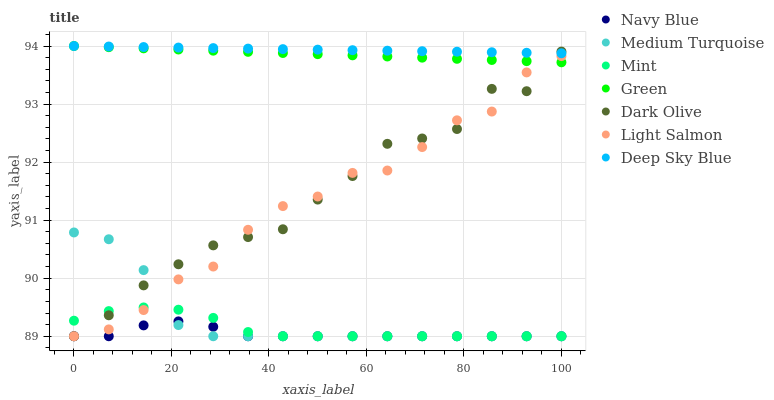Does Navy Blue have the minimum area under the curve?
Answer yes or no. Yes. Does Deep Sky Blue have the maximum area under the curve?
Answer yes or no. Yes. Does Deep Sky Blue have the minimum area under the curve?
Answer yes or no. No. Does Navy Blue have the maximum area under the curve?
Answer yes or no. No. Is Green the smoothest?
Answer yes or no. Yes. Is Light Salmon the roughest?
Answer yes or no. Yes. Is Deep Sky Blue the smoothest?
Answer yes or no. No. Is Deep Sky Blue the roughest?
Answer yes or no. No. Does Light Salmon have the lowest value?
Answer yes or no. Yes. Does Deep Sky Blue have the lowest value?
Answer yes or no. No. Does Green have the highest value?
Answer yes or no. Yes. Does Navy Blue have the highest value?
Answer yes or no. No. Is Mint less than Green?
Answer yes or no. Yes. Is Deep Sky Blue greater than Mint?
Answer yes or no. Yes. Does Dark Olive intersect Navy Blue?
Answer yes or no. Yes. Is Dark Olive less than Navy Blue?
Answer yes or no. No. Is Dark Olive greater than Navy Blue?
Answer yes or no. No. Does Mint intersect Green?
Answer yes or no. No. 